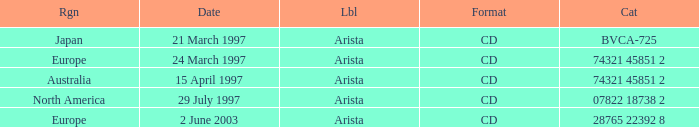What Date has the Region Europe and a Catalog of 74321 45851 2? 24 March 1997. 